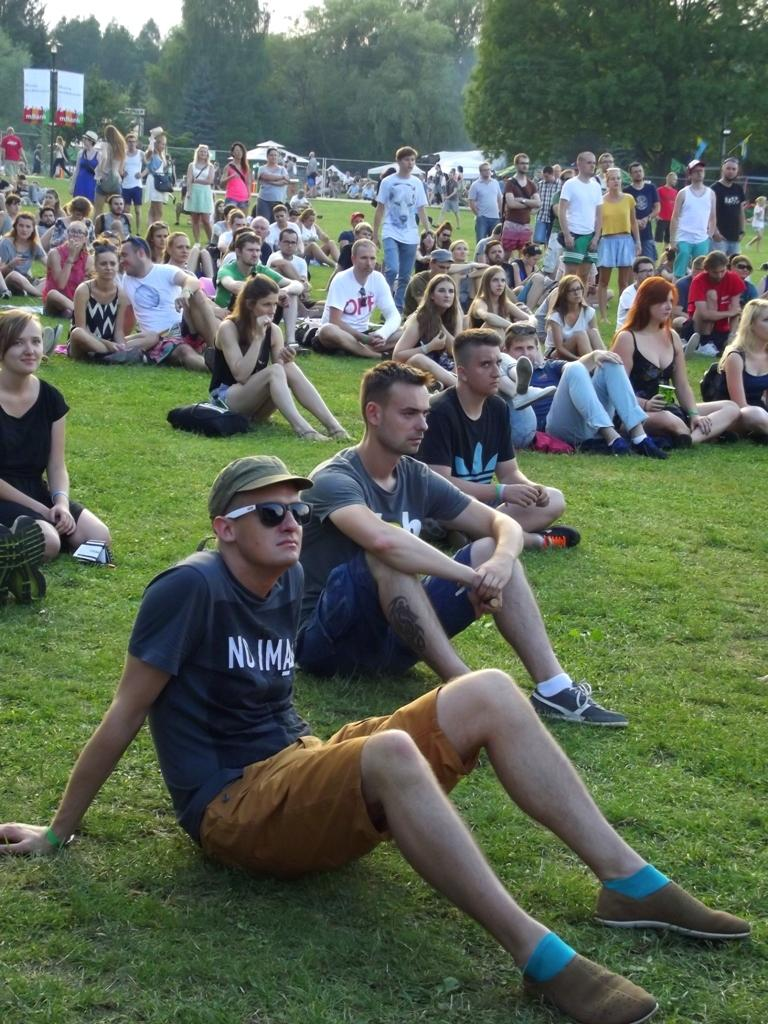What are the people in the image doing? There are people sitting on the grass and people standing in the image. What can be seen in the background of the image? There are trees, banners, and the sky visible in the background. What type of business is being conducted by the ghost in the image? There is no ghost present in the image, so no business can be conducted by a ghost. 